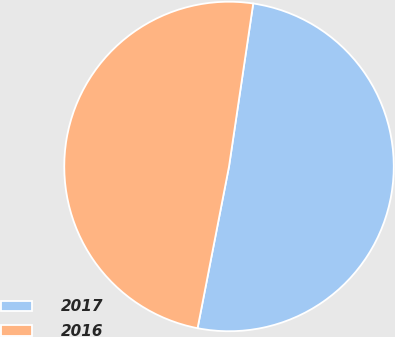Convert chart to OTSL. <chart><loc_0><loc_0><loc_500><loc_500><pie_chart><fcel>2017<fcel>2016<nl><fcel>50.71%<fcel>49.29%<nl></chart> 